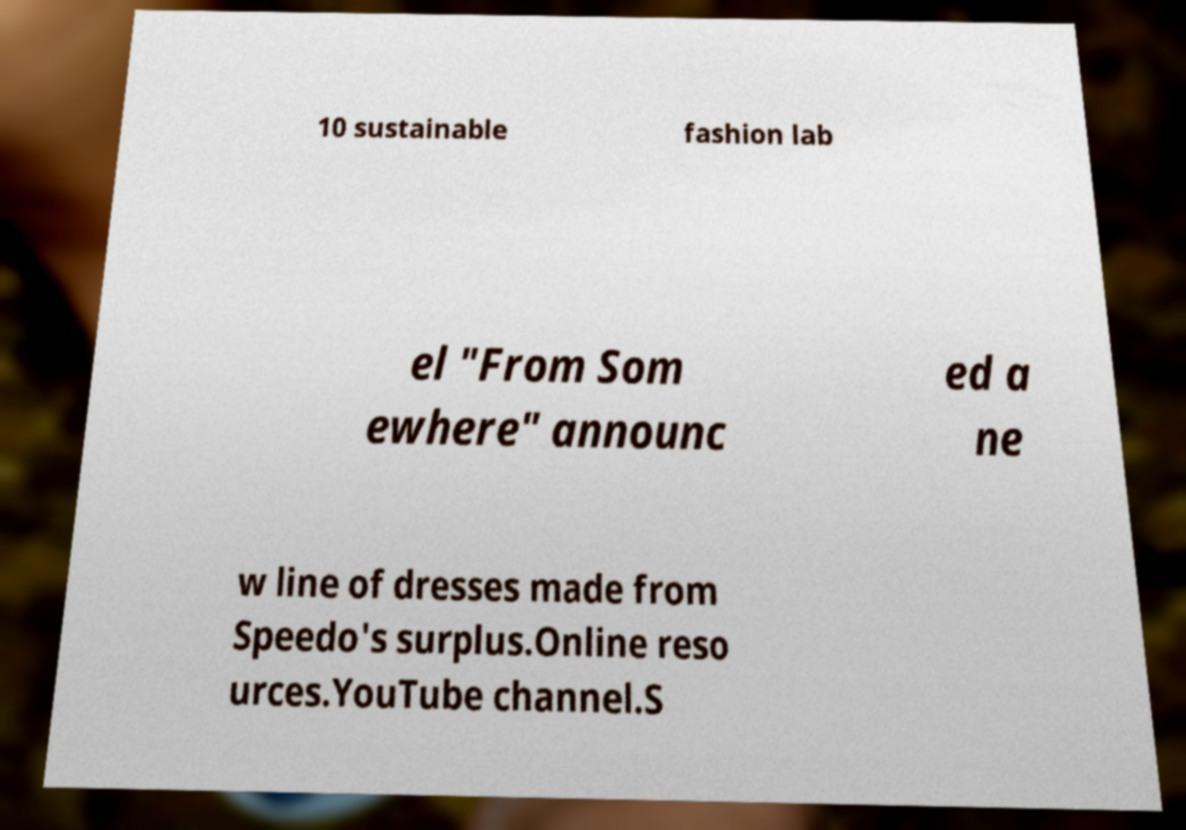There's text embedded in this image that I need extracted. Can you transcribe it verbatim? 10 sustainable fashion lab el "From Som ewhere" announc ed a ne w line of dresses made from Speedo's surplus.Online reso urces.YouTube channel.S 